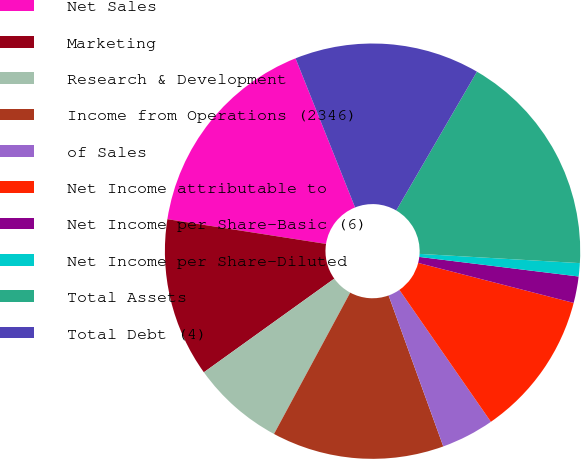Convert chart. <chart><loc_0><loc_0><loc_500><loc_500><pie_chart><fcel>Net Sales<fcel>Marketing<fcel>Research & Development<fcel>Income from Operations (2346)<fcel>of Sales<fcel>Net Income attributable to<fcel>Net Income per Share-Basic (6)<fcel>Net Income per Share-Diluted<fcel>Total Assets<fcel>Total Debt (4)<nl><fcel>16.49%<fcel>12.37%<fcel>7.22%<fcel>13.4%<fcel>4.12%<fcel>11.34%<fcel>2.06%<fcel>1.03%<fcel>17.53%<fcel>14.43%<nl></chart> 